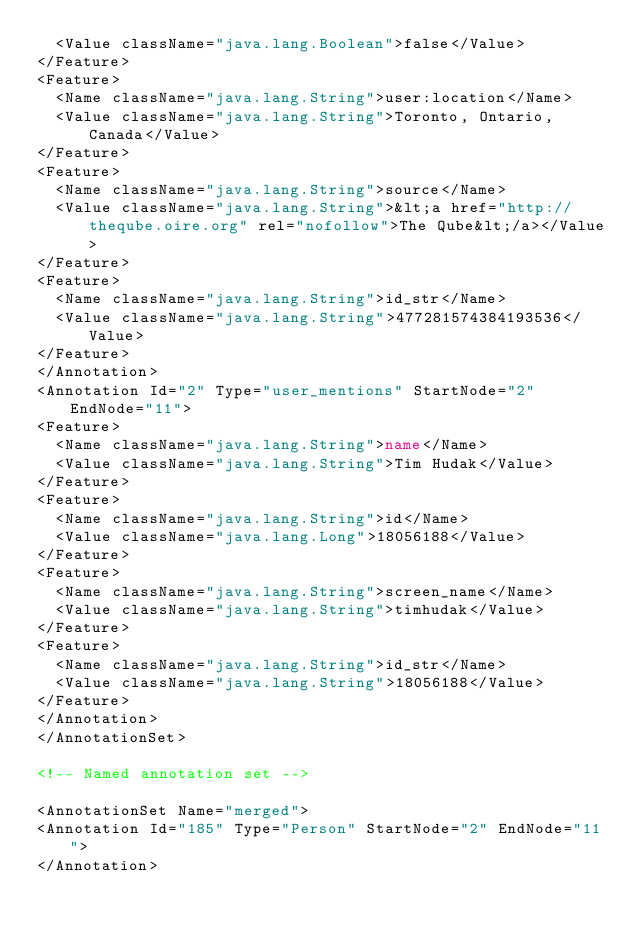<code> <loc_0><loc_0><loc_500><loc_500><_XML_>  <Value className="java.lang.Boolean">false</Value>
</Feature>
<Feature>
  <Name className="java.lang.String">user:location</Name>
  <Value className="java.lang.String">Toronto, Ontario, Canada</Value>
</Feature>
<Feature>
  <Name className="java.lang.String">source</Name>
  <Value className="java.lang.String">&lt;a href="http://theqube.oire.org" rel="nofollow">The Qube&lt;/a></Value>
</Feature>
<Feature>
  <Name className="java.lang.String">id_str</Name>
  <Value className="java.lang.String">477281574384193536</Value>
</Feature>
</Annotation>
<Annotation Id="2" Type="user_mentions" StartNode="2" EndNode="11">
<Feature>
  <Name className="java.lang.String">name</Name>
  <Value className="java.lang.String">Tim Hudak</Value>
</Feature>
<Feature>
  <Name className="java.lang.String">id</Name>
  <Value className="java.lang.Long">18056188</Value>
</Feature>
<Feature>
  <Name className="java.lang.String">screen_name</Name>
  <Value className="java.lang.String">timhudak</Value>
</Feature>
<Feature>
  <Name className="java.lang.String">id_str</Name>
  <Value className="java.lang.String">18056188</Value>
</Feature>
</Annotation>
</AnnotationSet>

<!-- Named annotation set -->

<AnnotationSet Name="merged">
<Annotation Id="185" Type="Person" StartNode="2" EndNode="11">
</Annotation></code> 